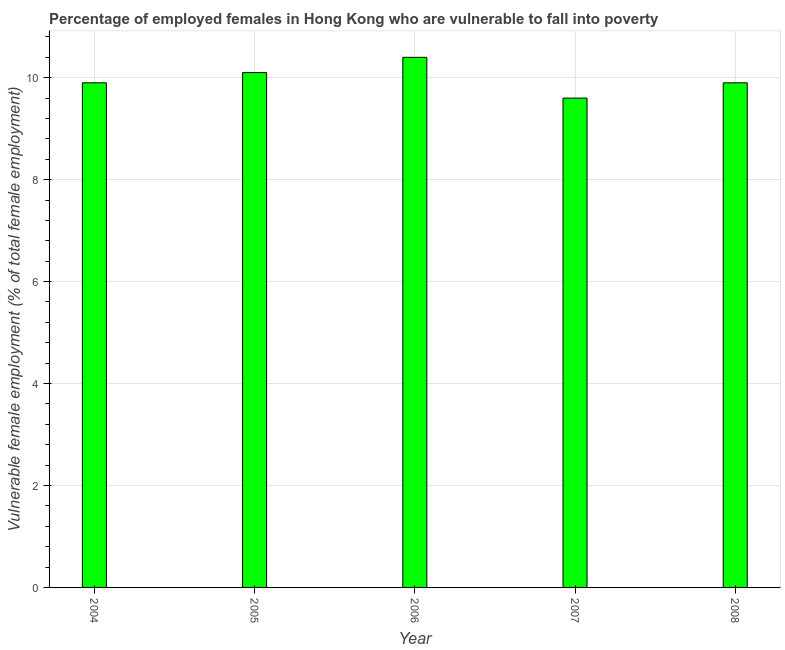Does the graph contain grids?
Your answer should be compact. Yes. What is the title of the graph?
Your answer should be compact. Percentage of employed females in Hong Kong who are vulnerable to fall into poverty. What is the label or title of the Y-axis?
Offer a very short reply. Vulnerable female employment (% of total female employment). What is the percentage of employed females who are vulnerable to fall into poverty in 2007?
Your answer should be compact. 9.6. Across all years, what is the maximum percentage of employed females who are vulnerable to fall into poverty?
Offer a very short reply. 10.4. Across all years, what is the minimum percentage of employed females who are vulnerable to fall into poverty?
Keep it short and to the point. 9.6. In which year was the percentage of employed females who are vulnerable to fall into poverty maximum?
Provide a short and direct response. 2006. What is the sum of the percentage of employed females who are vulnerable to fall into poverty?
Make the answer very short. 49.9. What is the average percentage of employed females who are vulnerable to fall into poverty per year?
Keep it short and to the point. 9.98. What is the median percentage of employed females who are vulnerable to fall into poverty?
Give a very brief answer. 9.9. What is the ratio of the percentage of employed females who are vulnerable to fall into poverty in 2006 to that in 2007?
Keep it short and to the point. 1.08. Is the percentage of employed females who are vulnerable to fall into poverty in 2006 less than that in 2007?
Your answer should be very brief. No. Is the difference between the percentage of employed females who are vulnerable to fall into poverty in 2006 and 2008 greater than the difference between any two years?
Offer a terse response. No. What is the difference between the highest and the second highest percentage of employed females who are vulnerable to fall into poverty?
Your answer should be very brief. 0.3. Is the sum of the percentage of employed females who are vulnerable to fall into poverty in 2005 and 2008 greater than the maximum percentage of employed females who are vulnerable to fall into poverty across all years?
Offer a very short reply. Yes. How many bars are there?
Offer a very short reply. 5. What is the Vulnerable female employment (% of total female employment) of 2004?
Give a very brief answer. 9.9. What is the Vulnerable female employment (% of total female employment) of 2005?
Ensure brevity in your answer.  10.1. What is the Vulnerable female employment (% of total female employment) in 2006?
Your response must be concise. 10.4. What is the Vulnerable female employment (% of total female employment) of 2007?
Your answer should be very brief. 9.6. What is the Vulnerable female employment (% of total female employment) in 2008?
Your answer should be very brief. 9.9. What is the difference between the Vulnerable female employment (% of total female employment) in 2004 and 2005?
Your response must be concise. -0.2. What is the difference between the Vulnerable female employment (% of total female employment) in 2004 and 2006?
Your response must be concise. -0.5. What is the difference between the Vulnerable female employment (% of total female employment) in 2004 and 2007?
Your answer should be compact. 0.3. What is the difference between the Vulnerable female employment (% of total female employment) in 2004 and 2008?
Provide a short and direct response. 0. What is the difference between the Vulnerable female employment (% of total female employment) in 2006 and 2007?
Provide a succinct answer. 0.8. What is the difference between the Vulnerable female employment (% of total female employment) in 2006 and 2008?
Provide a succinct answer. 0.5. What is the difference between the Vulnerable female employment (% of total female employment) in 2007 and 2008?
Offer a terse response. -0.3. What is the ratio of the Vulnerable female employment (% of total female employment) in 2004 to that in 2005?
Give a very brief answer. 0.98. What is the ratio of the Vulnerable female employment (% of total female employment) in 2004 to that in 2007?
Ensure brevity in your answer.  1.03. What is the ratio of the Vulnerable female employment (% of total female employment) in 2005 to that in 2007?
Offer a very short reply. 1.05. What is the ratio of the Vulnerable female employment (% of total female employment) in 2005 to that in 2008?
Provide a succinct answer. 1.02. What is the ratio of the Vulnerable female employment (% of total female employment) in 2006 to that in 2007?
Your answer should be compact. 1.08. What is the ratio of the Vulnerable female employment (% of total female employment) in 2006 to that in 2008?
Your answer should be very brief. 1.05. 